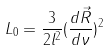Convert formula to latex. <formula><loc_0><loc_0><loc_500><loc_500>L _ { 0 } = \frac { 3 } { 2 l ^ { 2 } } ( \frac { d \vec { R } } { d \nu } ) ^ { 2 }</formula> 